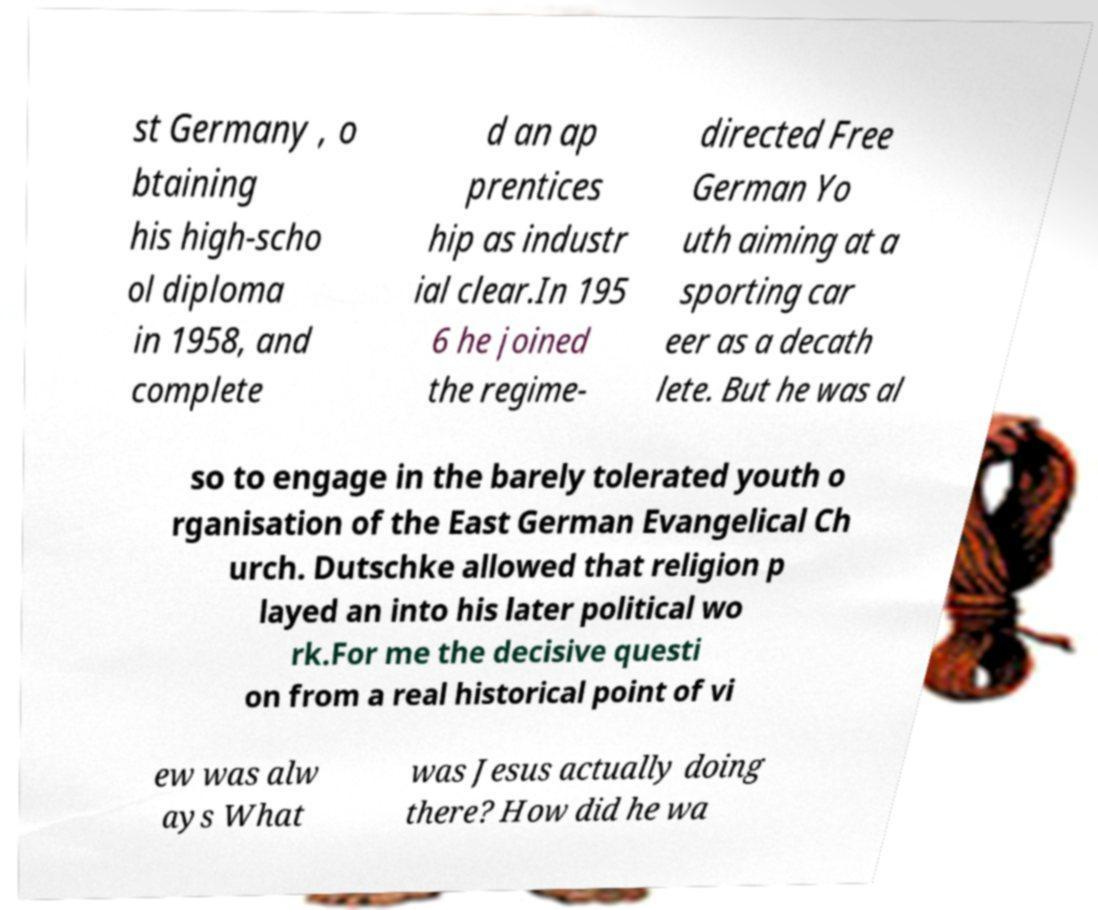Can you read and provide the text displayed in the image?This photo seems to have some interesting text. Can you extract and type it out for me? st Germany , o btaining his high-scho ol diploma in 1958, and complete d an ap prentices hip as industr ial clear.In 195 6 he joined the regime- directed Free German Yo uth aiming at a sporting car eer as a decath lete. But he was al so to engage in the barely tolerated youth o rganisation of the East German Evangelical Ch urch. Dutschke allowed that religion p layed an into his later political wo rk.For me the decisive questi on from a real historical point of vi ew was alw ays What was Jesus actually doing there? How did he wa 